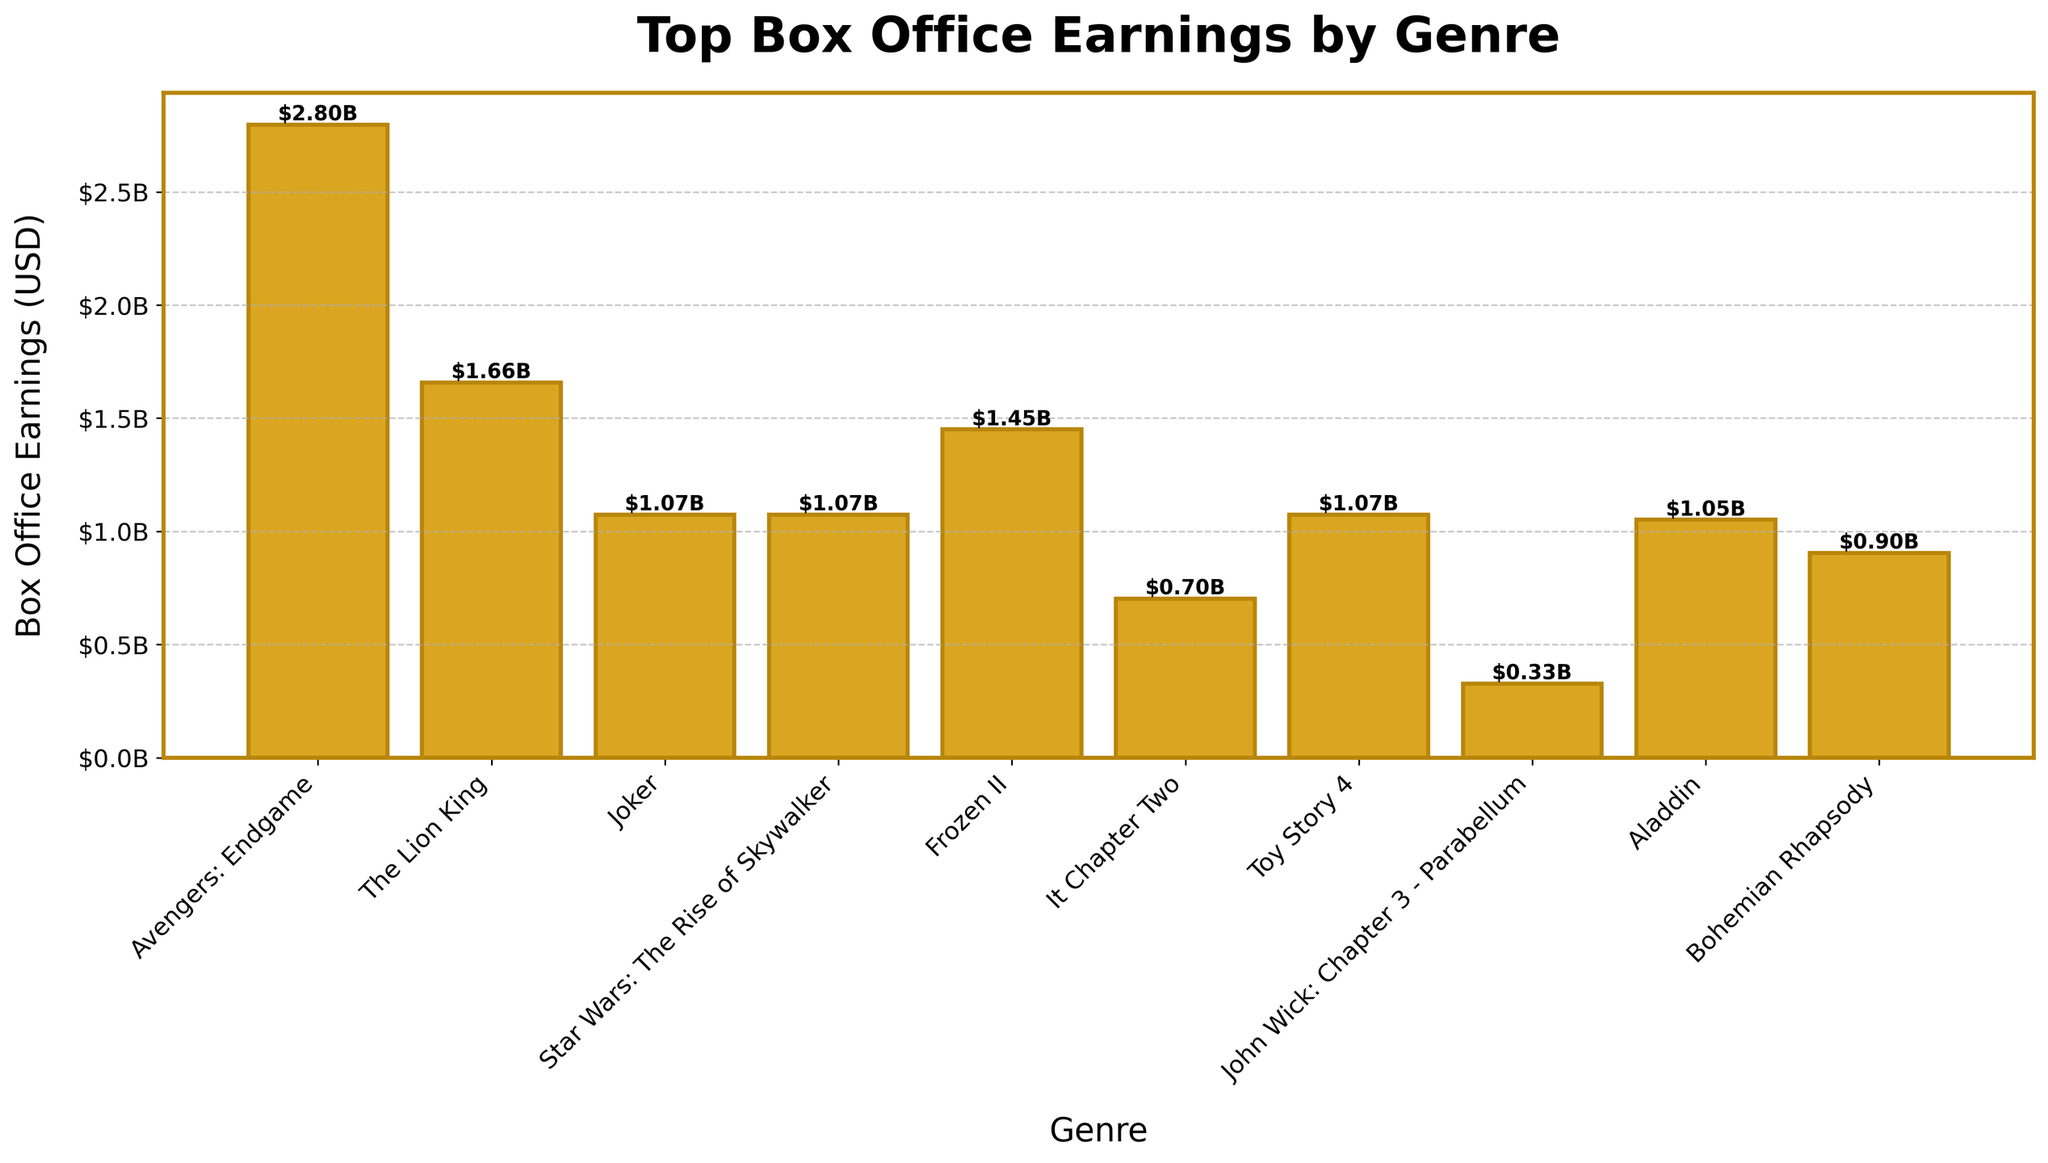Which genre has the highest box office earnings? Look at the height of the bars in the figure. The Action genre has the highest box office earnings as indicated by the tallest bar
Answer: Action Which genre has the lowest box office earnings according to the figure? Look at the height of the bars in the figure. The Thriller genre has the lowest box office earnings with the shortest bar shown
Answer: Thriller What is the difference in box office earnings between the highest and lowest earning genres? The bar for Action (highest) stands at about $2.80 billion, and Thriller (lowest) stands at $0.33 billion. The difference is $2.80 billion - $0.33 billion = $2.47 billion
Answer: $2.47 billion How many genres have box office earnings over $1 billion? By examining the height of the bars, Action, Comedy, Sci-Fi, Romance, Animation, and Fantasy are over $1 billion. Count these genres: 6
Answer: 6 Which two genres have box office earnings exactly between $1 billion and $2 billion? Look at the bars with heights within the $1 billion to $2 billion range. Comedy and Sci-Fi have earnings within this range
Answer: Comedy and Sci-Fi Are there more genres with box office earnings above or below $1 billion? Count the number of genres above $1 billion (Comedy, Sci-Fi, Romance, Animation, Fantasy). That is 5. Count the number of genres below $1 billion (Horror, Thriller, Musical). It is 3. There are more genres above $1 billion
Answer: Above What are the box office earnings for Comedy and Romance combined? Comedy stands at about $1.65 billion and Romance at about $1.45 billion. Adding these together: $1.65 billion + $1.45 billion = $3.10 billion
Answer: $3.10 billion Which genre has box office earnings closest to Sci-Fi? Compare the nearby bars to Sci-Fi, which stands at about $1.07 billion. Drama is the closest with a similar earnings of about $1.07 billion
Answer: Drama If you combine the box office earnings of Horror and Animation, do they surpass Action? Horror has about $0.70 billion and Animation has about $1.07 billion. Their combined earnings are $0.70 billion + $1.07 billion = $1.77 billion, which is less than Action's $2.80 billion
Answer: No What is the average box office earning of all the genres? Sum the earnings (Action: $2.80B, Comedy: $1.65B, Drama: $1.07B, Sci-Fi: $1.07B, Romance: $1.45B, Horror: $0.70B, Animation: $1.07B, Thriller: $0.33B, Fantasy: $1.05B, Musical: $0.90B) = $11.09 billion. Divide by 10 genres: $11.09 billion / 10 = $1.109 billion
Answer: $1.109 billion 